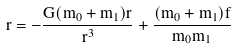Convert formula to latex. <formula><loc_0><loc_0><loc_500><loc_500>\ddot { r } = - \frac { G ( m _ { 0 } + m _ { 1 } ) r } { r ^ { 3 } } + \frac { ( m _ { 0 } + m _ { 1 } ) { f } } { m _ { 0 } m _ { 1 } }</formula> 